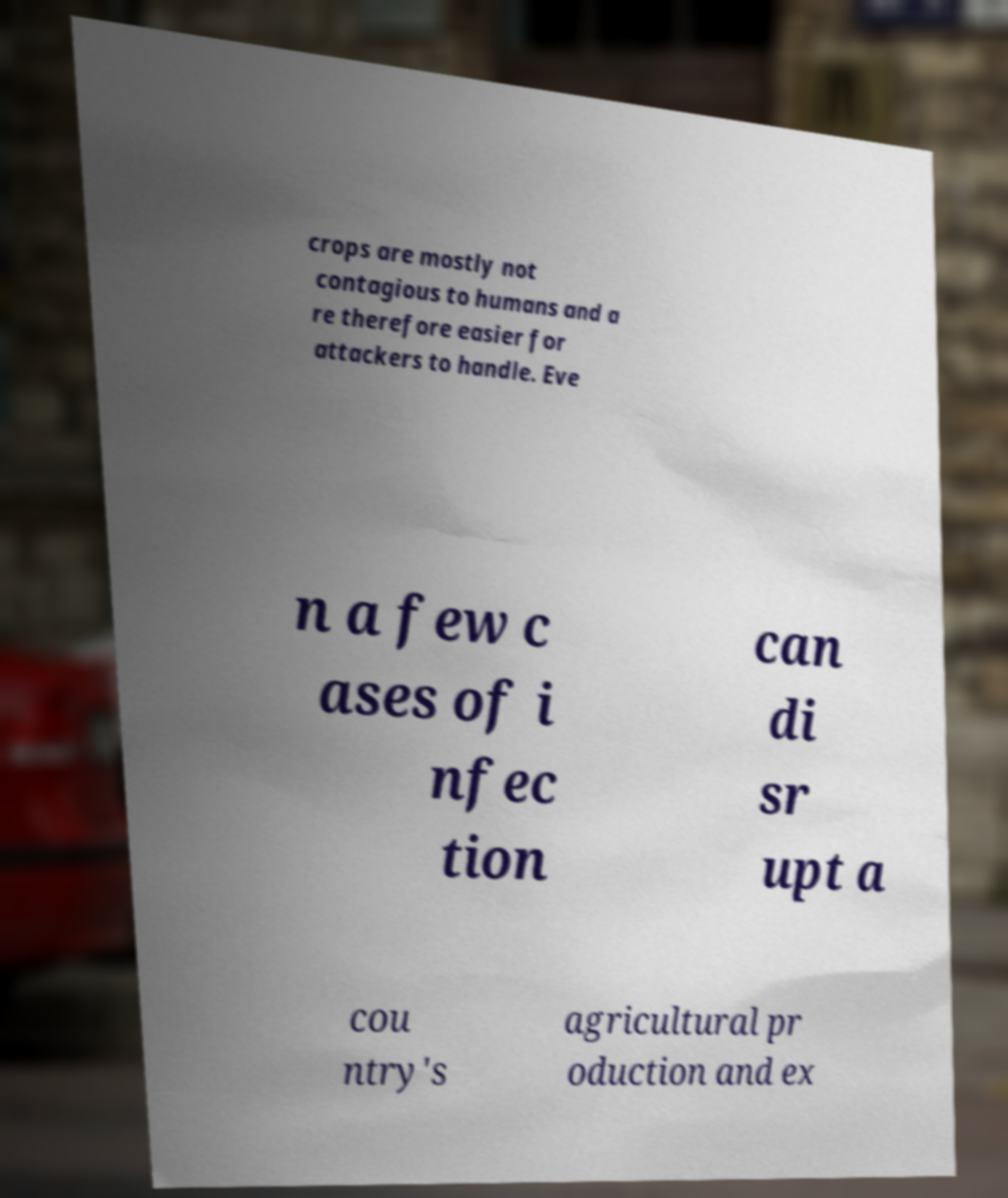Can you read and provide the text displayed in the image?This photo seems to have some interesting text. Can you extract and type it out for me? crops are mostly not contagious to humans and a re therefore easier for attackers to handle. Eve n a few c ases of i nfec tion can di sr upt a cou ntry's agricultural pr oduction and ex 